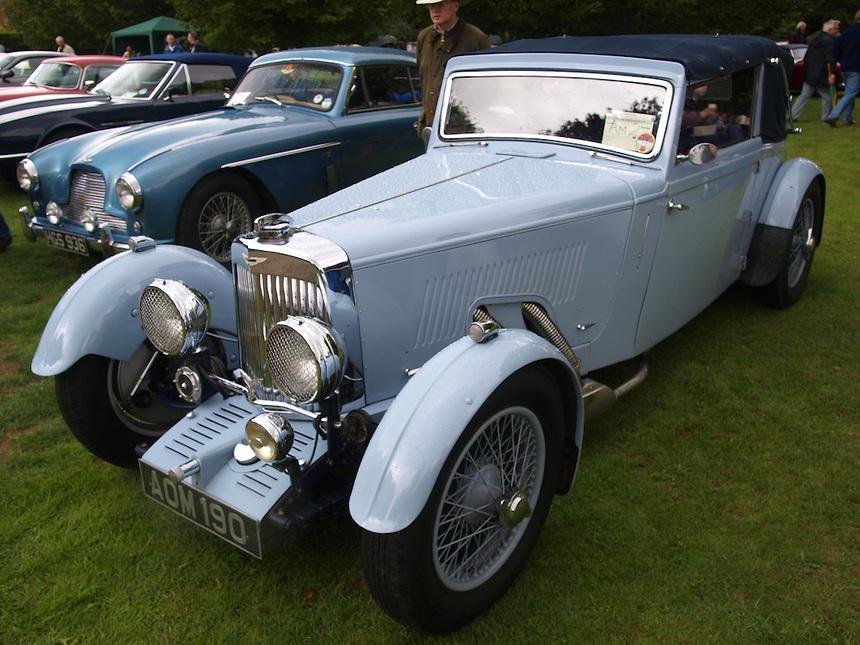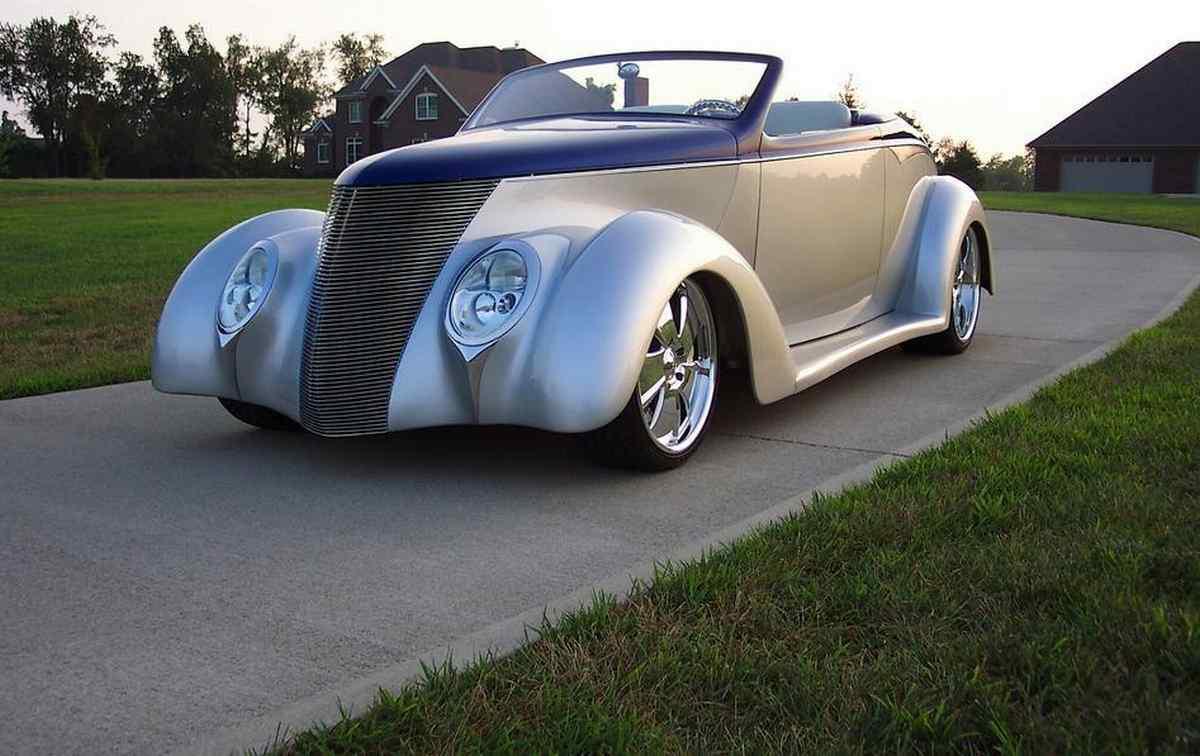The first image is the image on the left, the second image is the image on the right. Analyze the images presented: Is the assertion "The foreground cars in the left and right images face the same direction, and the righthand car is parked on a paved strip surrounded by grass and has a royal blue hood with a silver body." valid? Answer yes or no. Yes. The first image is the image on the left, the second image is the image on the right. For the images shown, is this caption "One car has a tan roof" true? Answer yes or no. No. 